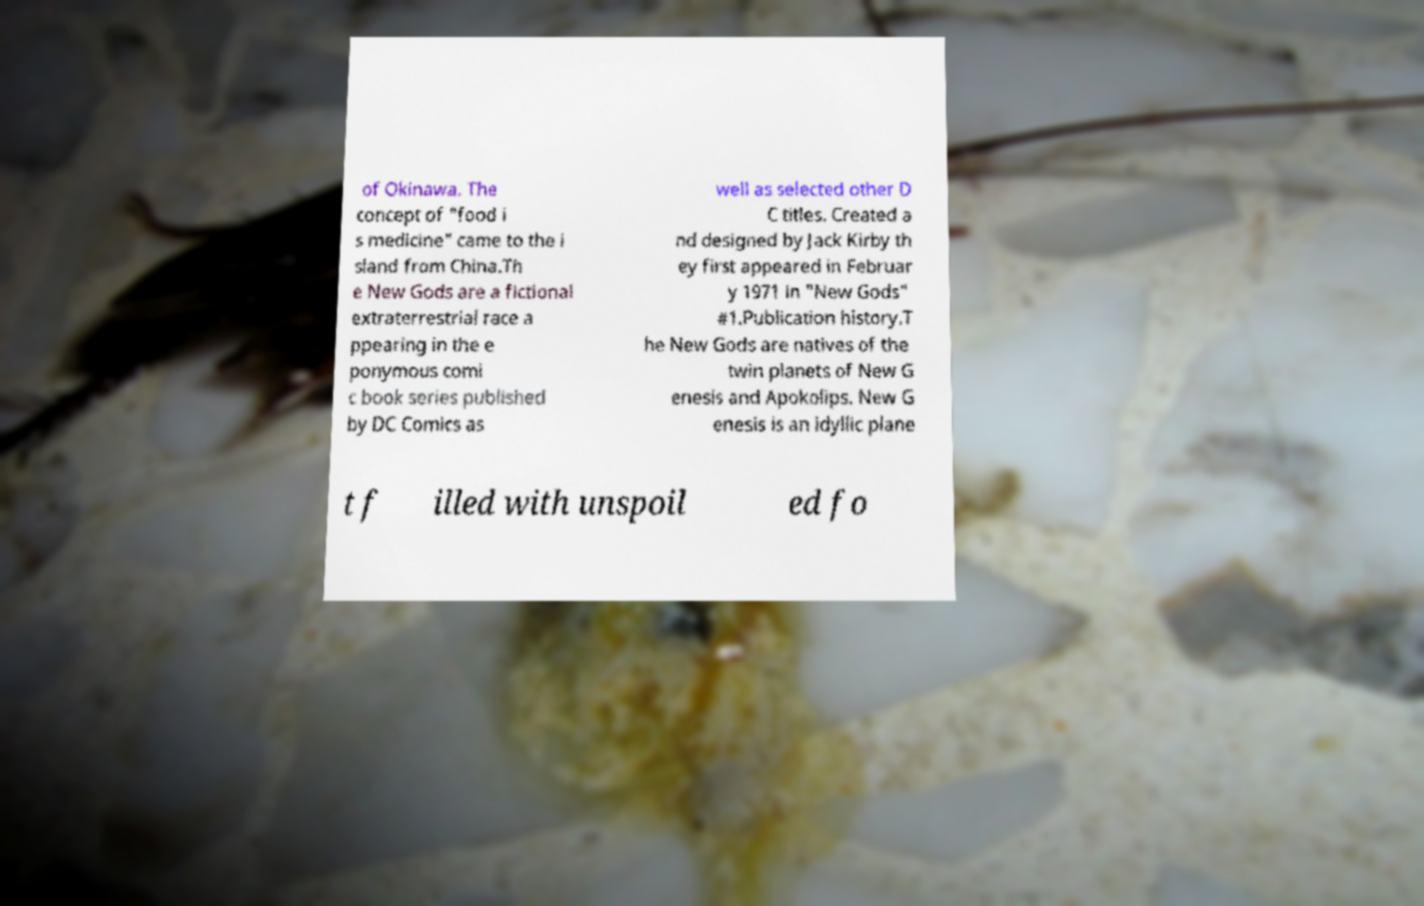There's text embedded in this image that I need extracted. Can you transcribe it verbatim? of Okinawa. The concept of "food i s medicine" came to the i sland from China.Th e New Gods are a fictional extraterrestrial race a ppearing in the e ponymous comi c book series published by DC Comics as well as selected other D C titles. Created a nd designed by Jack Kirby th ey first appeared in Februar y 1971 in "New Gods" #1.Publication history.T he New Gods are natives of the twin planets of New G enesis and Apokolips. New G enesis is an idyllic plane t f illed with unspoil ed fo 